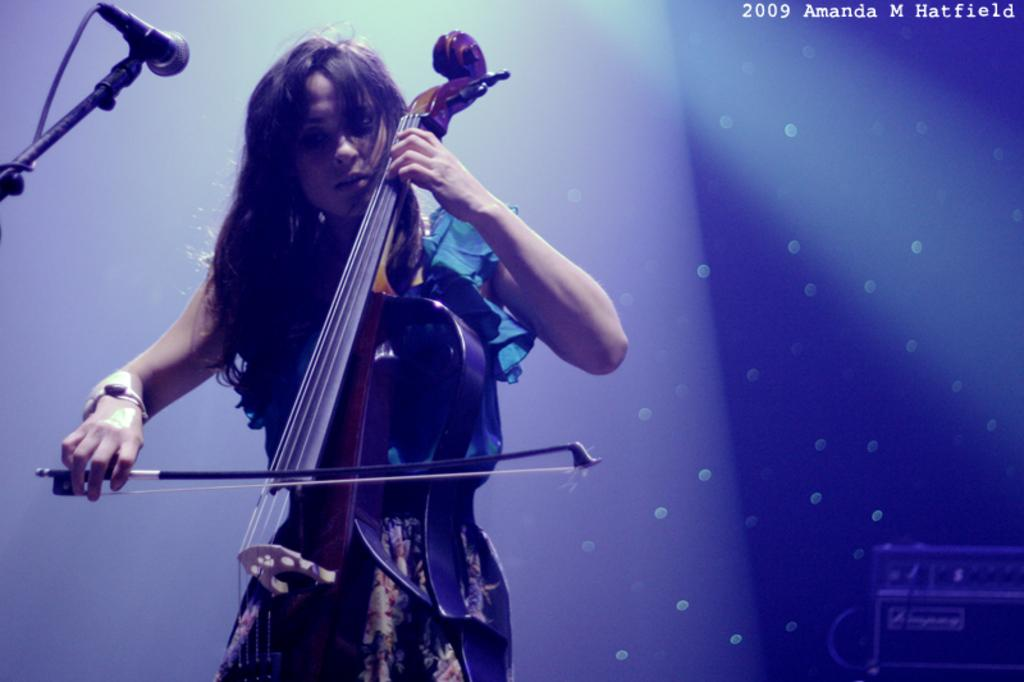What is the main subject of the image? The main subject of the image is a woman. What is the woman holding in the image? The woman is holding a violin. What is the woman doing with the violin? The woman is playing the violin. What device is present in the image that might be used for amplifying sound? There is a microphone in the image. What type of body does the woman have in the image? The image does not provide information about the woman's body, so it cannot be determined from the picture. What kind of haircut does the woman have in the image? The image does not provide information about the woman's haircut, so it cannot be determined from the picture. 